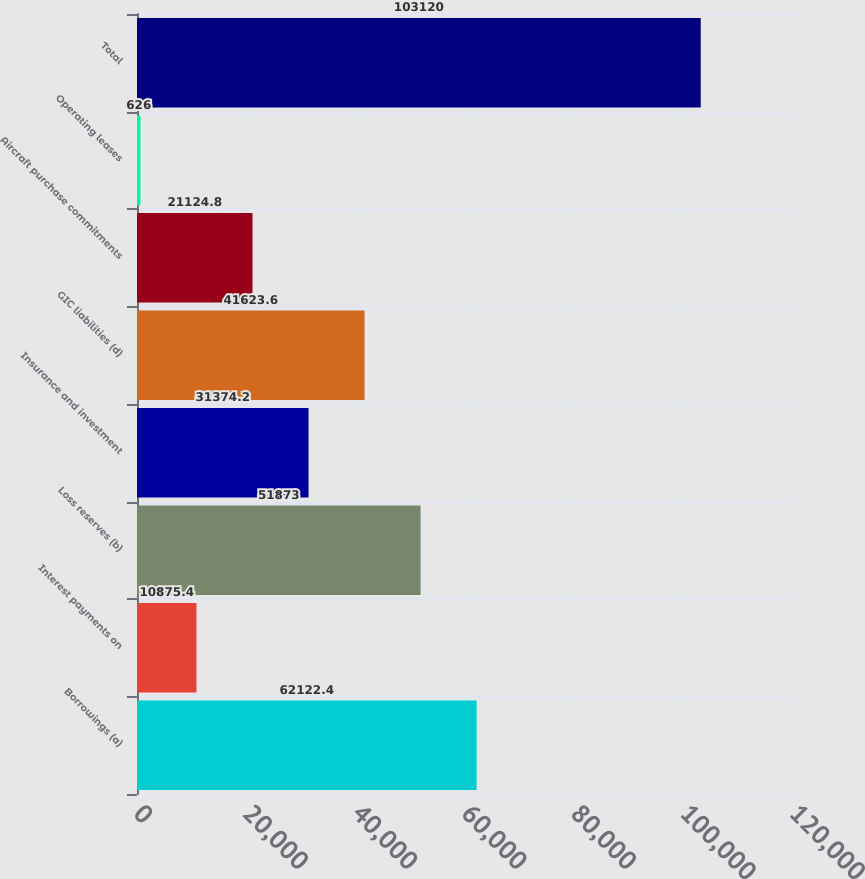Convert chart to OTSL. <chart><loc_0><loc_0><loc_500><loc_500><bar_chart><fcel>Borrowings (a)<fcel>Interest payments on<fcel>Loss reserves (b)<fcel>Insurance and investment<fcel>GIC liabilities (d)<fcel>Aircraft purchase commitments<fcel>Operating leases<fcel>Total<nl><fcel>62122.4<fcel>10875.4<fcel>51873<fcel>31374.2<fcel>41623.6<fcel>21124.8<fcel>626<fcel>103120<nl></chart> 